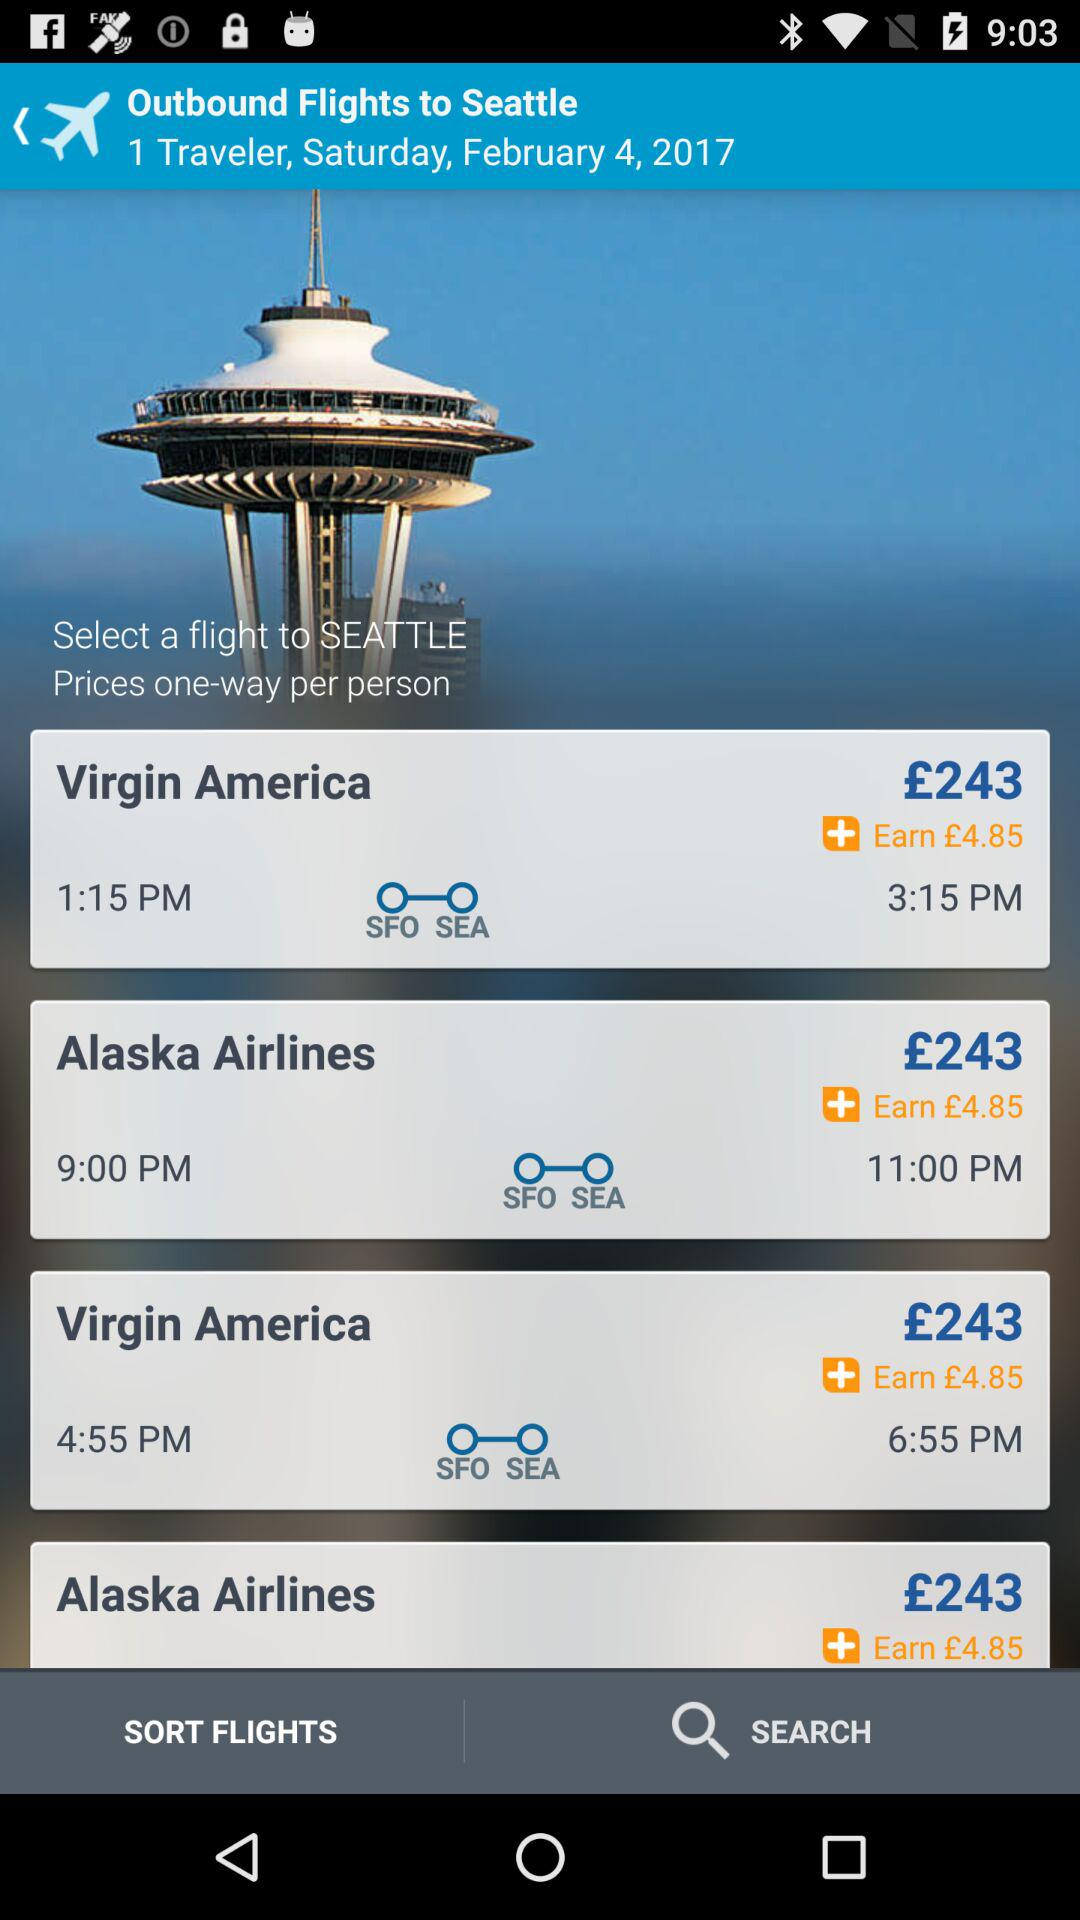What is the mentioned date? The mentioned date is Saturday, February 4, 2017. 